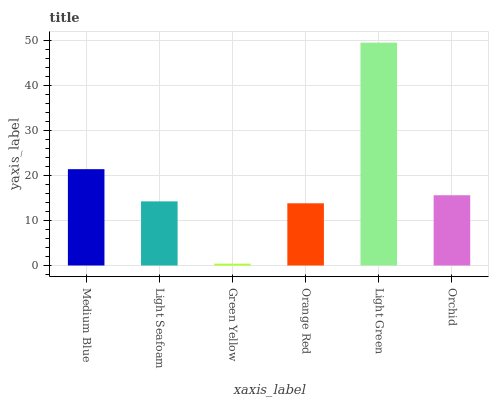Is Green Yellow the minimum?
Answer yes or no. Yes. Is Light Green the maximum?
Answer yes or no. Yes. Is Light Seafoam the minimum?
Answer yes or no. No. Is Light Seafoam the maximum?
Answer yes or no. No. Is Medium Blue greater than Light Seafoam?
Answer yes or no. Yes. Is Light Seafoam less than Medium Blue?
Answer yes or no. Yes. Is Light Seafoam greater than Medium Blue?
Answer yes or no. No. Is Medium Blue less than Light Seafoam?
Answer yes or no. No. Is Orchid the high median?
Answer yes or no. Yes. Is Light Seafoam the low median?
Answer yes or no. Yes. Is Light Green the high median?
Answer yes or no. No. Is Orange Red the low median?
Answer yes or no. No. 